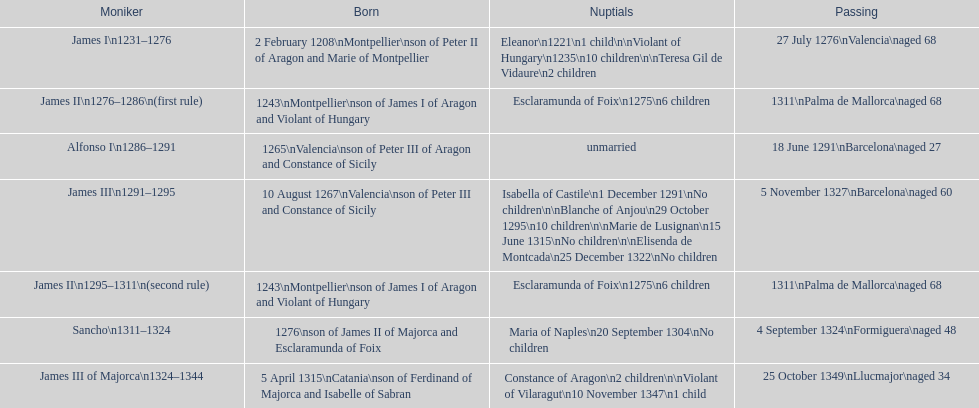Which monarch is listed first? James I 1231-1276. 